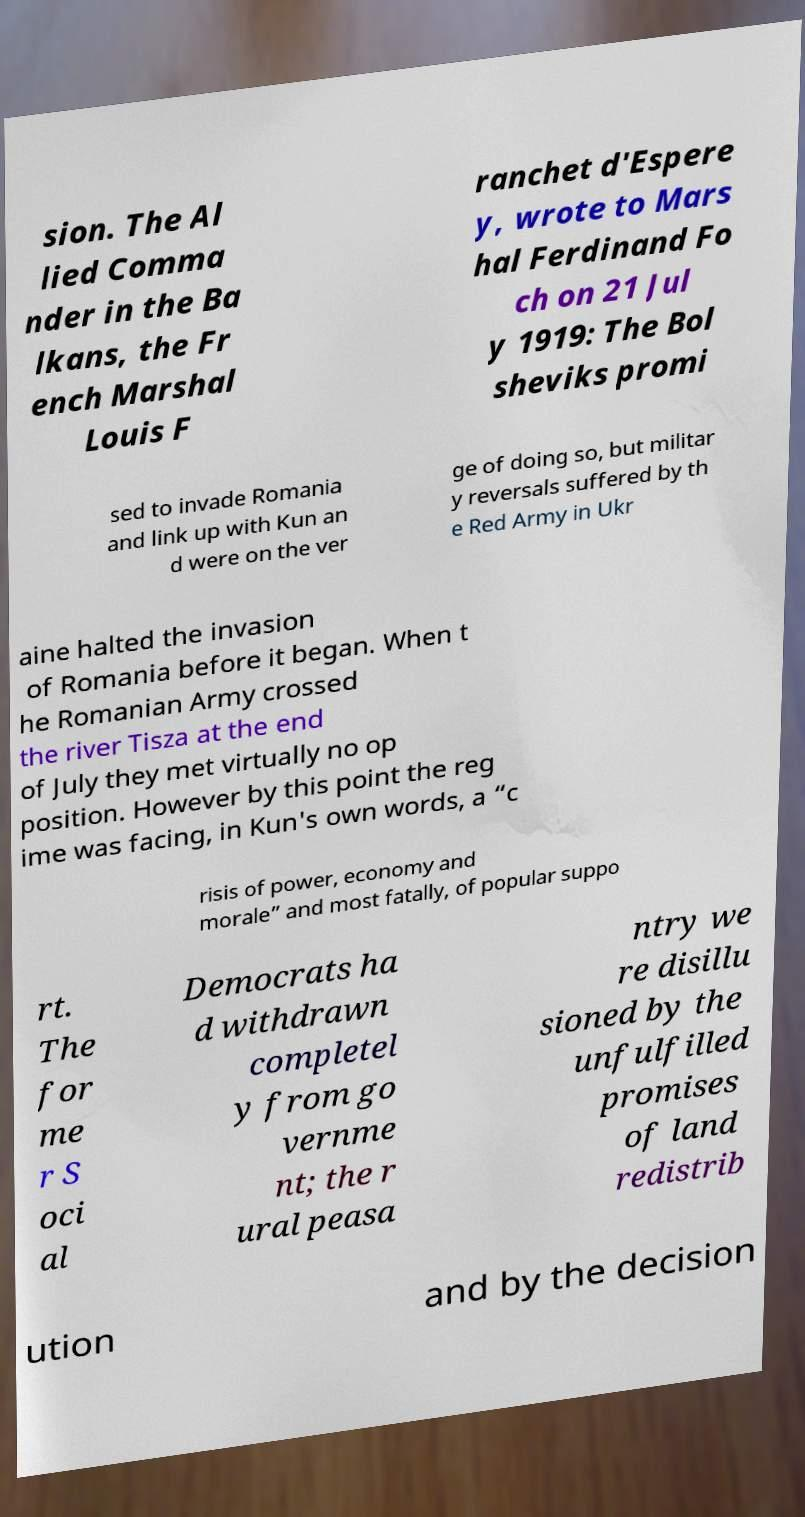Please read and relay the text visible in this image. What does it say? sion. The Al lied Comma nder in the Ba lkans, the Fr ench Marshal Louis F ranchet d'Espere y, wrote to Mars hal Ferdinand Fo ch on 21 Jul y 1919: The Bol sheviks promi sed to invade Romania and link up with Kun an d were on the ver ge of doing so, but militar y reversals suffered by th e Red Army in Ukr aine halted the invasion of Romania before it began. When t he Romanian Army crossed the river Tisza at the end of July they met virtually no op position. However by this point the reg ime was facing, in Kun's own words, a “c risis of power, economy and morale” and most fatally, of popular suppo rt. The for me r S oci al Democrats ha d withdrawn completel y from go vernme nt; the r ural peasa ntry we re disillu sioned by the unfulfilled promises of land redistrib ution and by the decision 